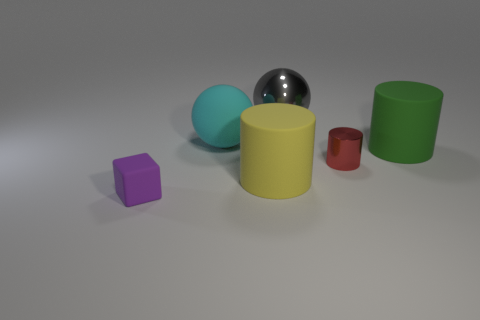What is the material of the small red object that is the same shape as the yellow matte object?
Your response must be concise. Metal. What is the shape of the matte thing that is the same size as the metal cylinder?
Provide a short and direct response. Cube. Are there any other yellow things of the same shape as the small metallic object?
Keep it short and to the point. Yes. There is a shiny object left of the metallic cylinder that is in front of the large cyan sphere; what shape is it?
Ensure brevity in your answer.  Sphere. What shape is the gray metallic thing?
Your answer should be compact. Sphere. There is a large cylinder to the right of the big yellow matte object left of the tiny thing that is behind the purple matte cube; what is it made of?
Keep it short and to the point. Rubber. How many other objects are there of the same material as the big gray sphere?
Your answer should be compact. 1. There is a big rubber object that is to the right of the big shiny thing; how many metallic balls are on the right side of it?
Ensure brevity in your answer.  0. What number of spheres are large cyan things or purple things?
Make the answer very short. 1. There is a object that is behind the small shiny thing and in front of the cyan rubber thing; what color is it?
Give a very brief answer. Green. 